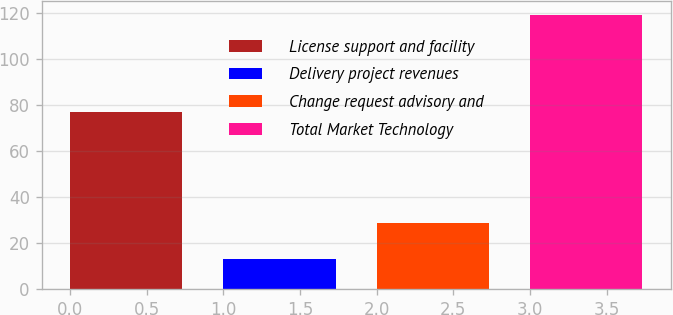Convert chart to OTSL. <chart><loc_0><loc_0><loc_500><loc_500><bar_chart><fcel>License support and facility<fcel>Delivery project revenues<fcel>Change request advisory and<fcel>Total Market Technology<nl><fcel>77<fcel>13<fcel>29<fcel>119<nl></chart> 